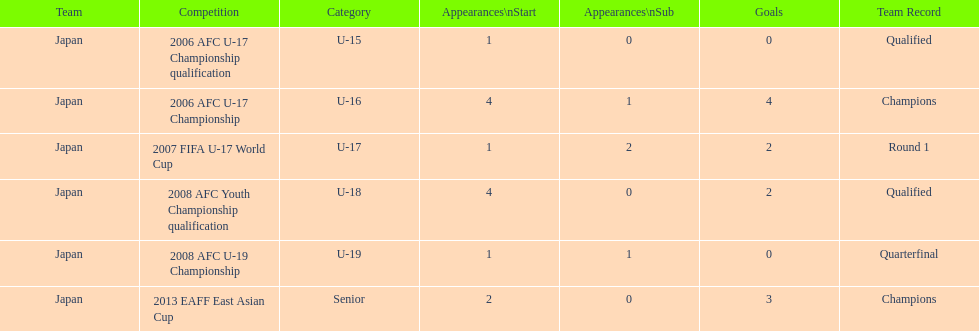Where did japan only score four goals? 2006 AFC U-17 Championship. 